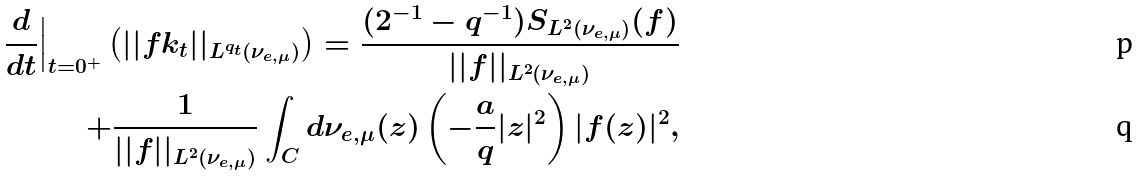Convert formula to latex. <formula><loc_0><loc_0><loc_500><loc_500>\frac { d } { d t } \Big | _ { t = 0 ^ { + } } \left ( | | f k _ { t } | | _ { L ^ { q _ { t } } \left ( \nu _ { e , \mu } \right ) } \right ) = \frac { ( 2 ^ { - 1 } - q ^ { - 1 } ) S _ { L ^ { 2 } ( \nu _ { e , \mu } ) } ( f ) } { | | f | | _ { L ^ { 2 } ( \nu _ { e , \mu } ) } } \\ + \frac { 1 } { | | f | | _ { L ^ { 2 } ( \nu _ { e , \mu } ) } } \int _ { C } d \nu _ { e , \mu } ( z ) \left ( - \frac { a } { q } | z | ^ { 2 } \right ) | f ( z ) | ^ { 2 } ,</formula> 